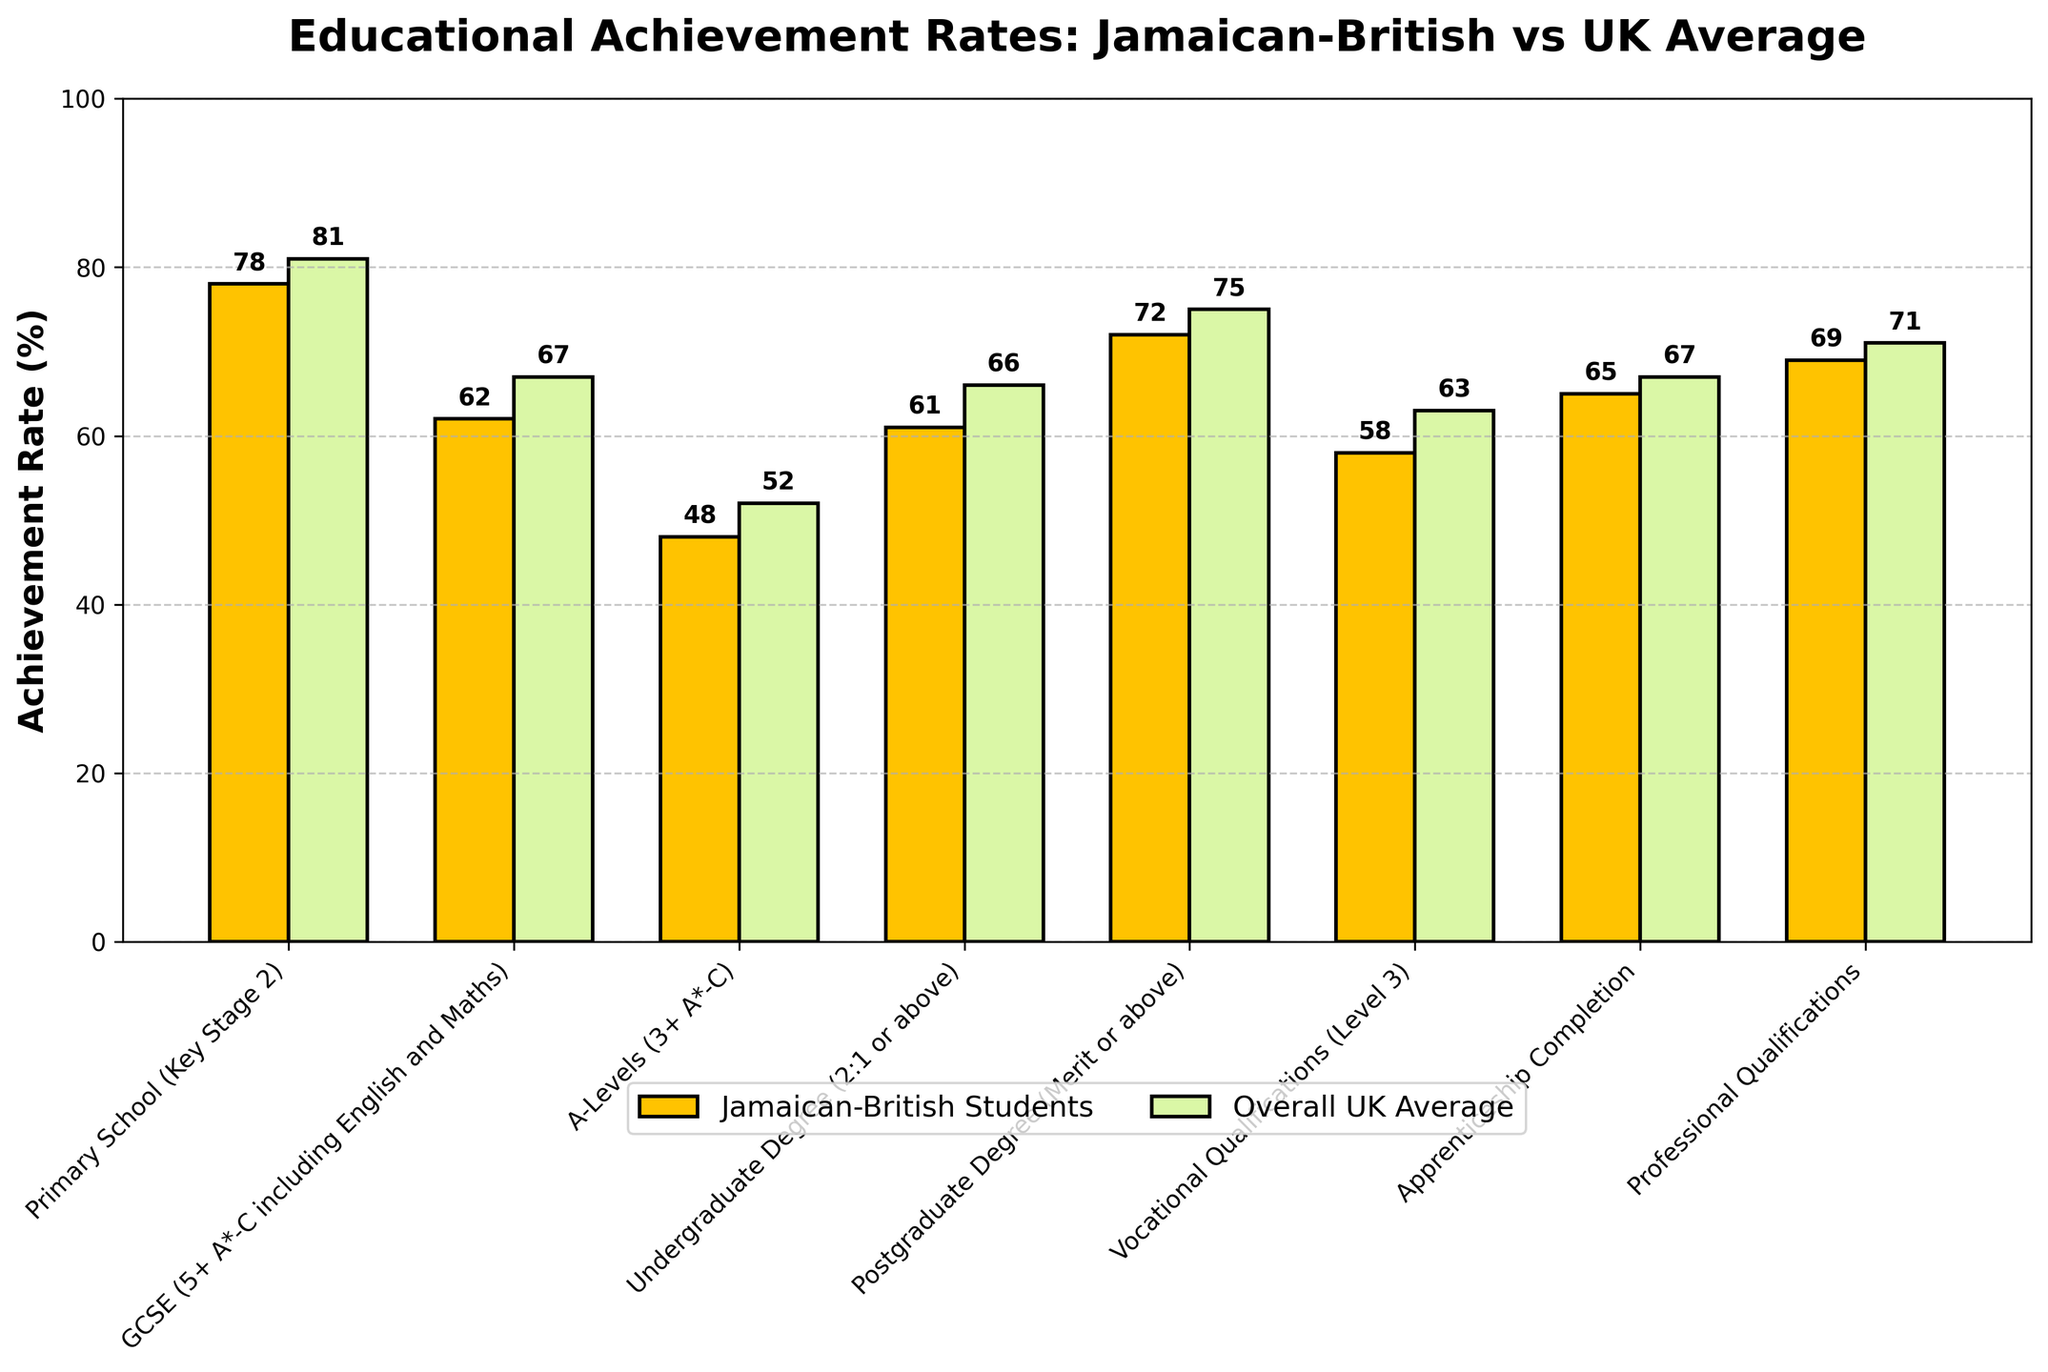Which academic level has the smallest difference in achievement rates between Jamaican-British students and the overall UK average? Look at the bars in the graph for each academic level. Calculate the differences: Primary School (3), GCSE (5), A-Levels (4), Undergraduate Degree (5), Postgraduate Degree (3), Vocational Qualifications (5), Apprenticeship Completion (2), Professional Qualifications (2). The smallest differences, 2%, are for Apprenticeship Completion and Professional Qualifications.
Answer: Apprenticeship Completion and Professional Qualifications Which academic level shows the largest achievement rate for Jamaican-British students? Examine the height of the bars corresponding to Jamaican-British students. The tallest bar represents the largest achievement rate.
Answer: Postgraduate Degree What is the average achievement rate of Jamaican-British students across all academic levels? Sum all the Jamaican-British achievement rates: 78 + 62 + 48 + 61 + 72 + 58 + 65 + 69. Divide by the number of academic levels (8).
Answer: 64.13 How does the achievement rate for GCSEs compare between Jamaican-British students and the overall UK average? Look at the bars labeled for GCSE achievement rates. Jamaican-British students have a 62% achievement rate, and the overall UK average shows 67%. Thus, the Jamaican-British rate is lower.
Answer: Jamaican-British students' rate is 5% lower Which academic level has the widest gap between Jamaican-British students and the overall UK average? Calculate the differences between the bars for each academic level: Primary School (3), GCSE (5), A-Levels (4), Undergraduate Degree (5), Postgraduate Degree (3), Vocational Qualifications (5), Apprenticeship Completion (2), Professional Qualifications (2). The largest difference is 5%, and it occurs in Multiple levels (GCSE, Undergraduate Degree, and Vocational Qualifications).
Answer: GCSE, Undergraduate Degree, and Vocational Qualifications Which group's bar has the highest value for Primary School (Key Stage 2)? Compare the heights of the two bars for Primary School; one is for Jamaican-British students (78%) and the other for the overall UK average (81%). The taller bar is for the overall UK average.
Answer: Overall UK Average What's the difference in achievement rates for Jamaican-British students between Undergraduate and Postgraduate degrees? Subtract the percentage for Undergraduate Degrees (61%) from Postgraduate Degrees (72%).
Answer: 11% On average, how much higher are the overall UK average achievement rates compared to Jamaican-British students? Sum the overall UK average percentages and Jamaican-British percentages separately: (81 + 67 + 52 + 66 + 75 + 63 + 67 + 71) = 542 and (78 + 62 + 48 + 61 + 72 + 58 + 65 + 69) = 513. Subtract the two totals, then divide by the number of academic levels (8).
Answer: 3.625 Which academic level does not follow the general trend of higher overall UK averages compared to Jamaican-British students? Find the academic level where the bar for Jamaican-British students is taller, equal to, or very close in height to the overall UK average. None fall into this category precisely, but all have slightly lower Jamaican-British rates.
Answer: None 